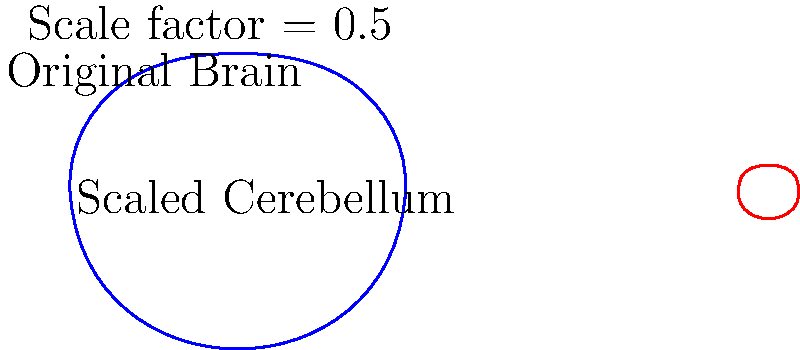In the diagram, a scaled version of the cerebellum is shown next to a full brain outline. If the actual cerebellum occupies approximately 10% of the brain's total volume, what is the approximate volume percentage of the scaled cerebellum compared to the original brain outline? To solve this problem, we need to understand the concept of scaling in three dimensions:

1. The cerebellum has been scaled by a factor of 0.5 in each dimension (length, width, height).
2. Volume scales with the cube of the linear scaling factor.
3. The volume scale factor is thus: $0.5^3 = 0.125$ or $\frac{1}{8}$

Now, let's calculate:

1. Original cerebellum volume: 10% of brain volume
2. Scaled cerebellum volume: $10\% \times \frac{1}{8} = 1.25\%$ of original brain volume

Therefore, the scaled cerebellum occupies approximately 1.25% of the volume of the original brain outline.
Answer: 1.25% 